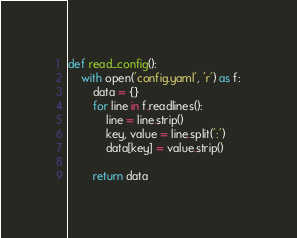Convert code to text. <code><loc_0><loc_0><loc_500><loc_500><_Python_>def read_config():
    with open('config.yaml', 'r') as f:
        data = {}
        for line in f.readlines():
            line = line.strip()
            key, value = line.split(':')
            data[key] = value.strip()
        
        return data</code> 